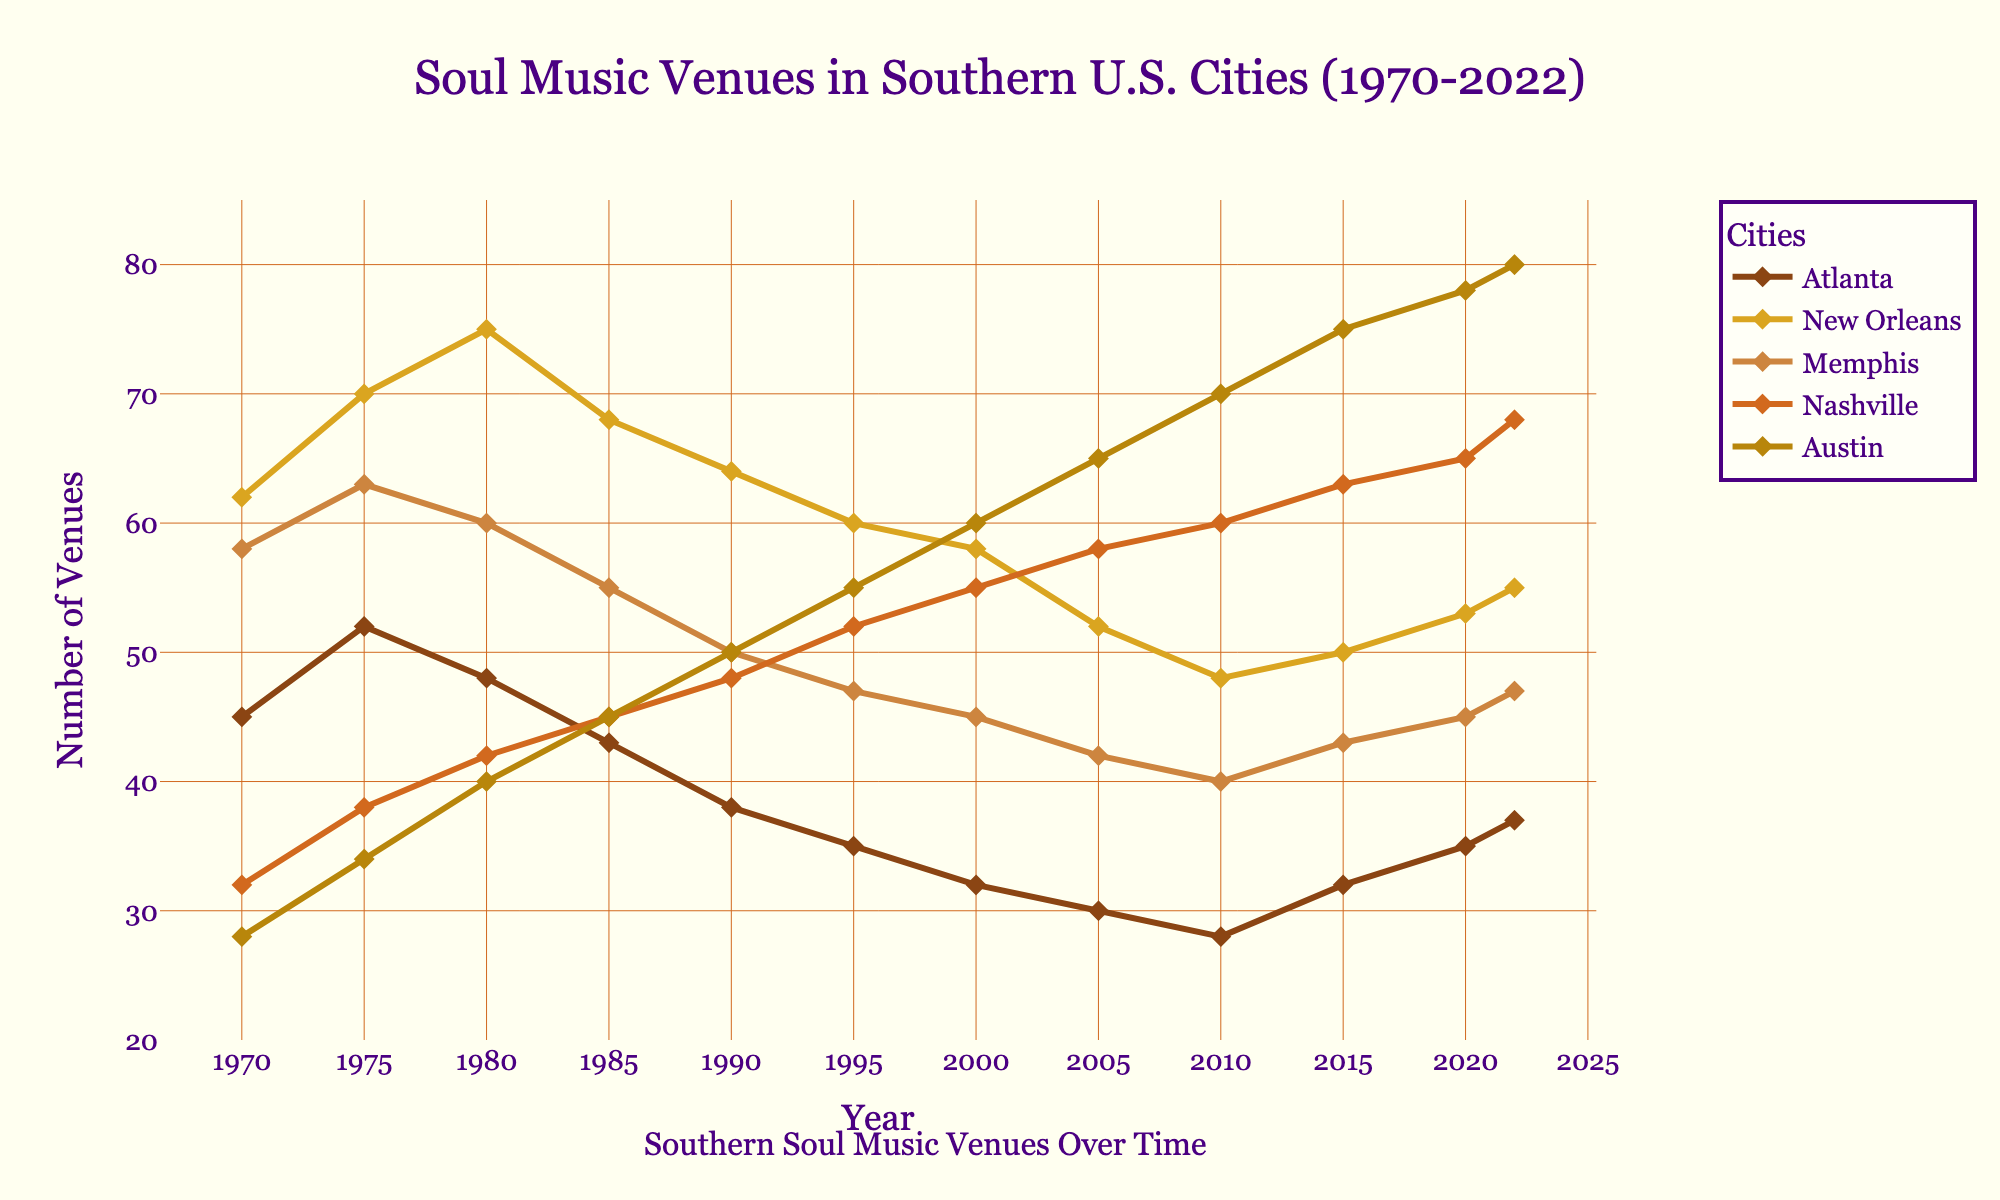What city had the highest number of soul music venues in 1970? The visual data indicates that New Orleans had the highest number of soul music venues in 1970.
Answer: New Orleans How did the number of soul music venues in Austin change between 1970 and 2022? In 1970, Austin had 28 venues. By 2022, this number increased to 80. The difference between 2022 and 1970 is 80 - 28 = 52.
Answer: Increased by 52 Which city experienced the largest decrease in the number of soul music venues from 1970 to 2010? Comparing the data visually, Atlanta had 45 venues in 1970 and 28 in 2010, which is a decrease of 17 venues. This is the largest decrease among the cities listed.
Answer: Atlanta When did Nashville surpass Memphis in the number of soul music venues? In 1995, Nashville had 52 venues, while Memphis had 47, marking the first time Nashville had more venues than Memphis.
Answer: 1995 What is the mean number of soul music venues in New Orleans over the entire period? To calculate the mean, add the number of venues in New Orleans for each year and divide by the number of years: (62+70+75+68+64+60+58+52+48+50+53+55) / 12 = 715 / 12 ≈ 59.6
Answer: 59.6 In which year did Memphis have the most venues, and how many did it have? Visually inspecting the heights of the lines, Memphis had the most venues in 1975 with 63 venues.
Answer: 1975, 63 Compare the trend of soul music venues in Austin and Nashville from 1970 to 2022. Which city saw a more substantial increase? Both cities showed an upward trend, but Austin’s increase (28 to 80) of 52 venues is more substantial than Nashville’s increase (32 to 68) of 36 venues over the same period.
Answer: Austin What is the combined number of soul music venues in Atlanta and Austin in 2022? In 2022, Atlanta has 37 venues, and Austin has 80. The combined number is 37 + 80 = 117.
Answer: 117 Which city showed a consistent upward trend in the number of soul music venues from 2000 to 2022? Visual inspection shows that Austin consistently had an upward trend during this period, with the number of venues steadily increasing from 2000 to 2022.
Answer: Austin How does the number of venues in New Orleans in 1980 compare to that in 2020? In 1980, New Orleans had 75 venues, while in 2020, it had 53 venues. Therefore, it decreased from 75 to 53.
Answer: Decreased by 22 